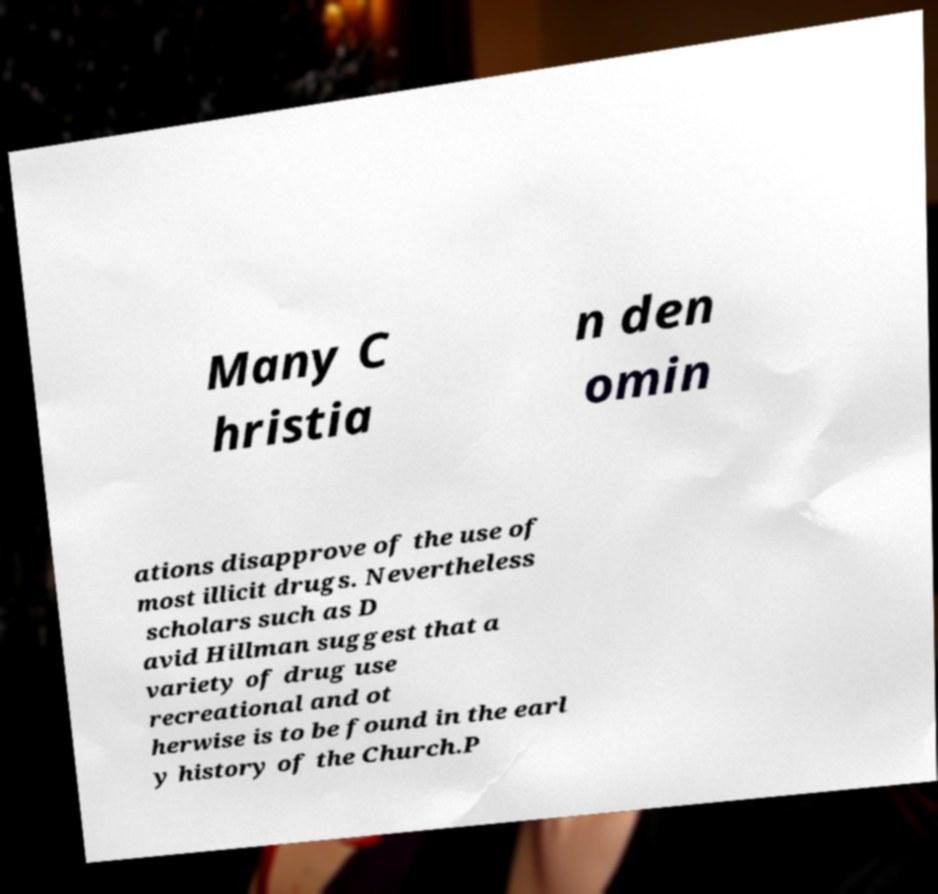Can you accurately transcribe the text from the provided image for me? Many C hristia n den omin ations disapprove of the use of most illicit drugs. Nevertheless scholars such as D avid Hillman suggest that a variety of drug use recreational and ot herwise is to be found in the earl y history of the Church.P 